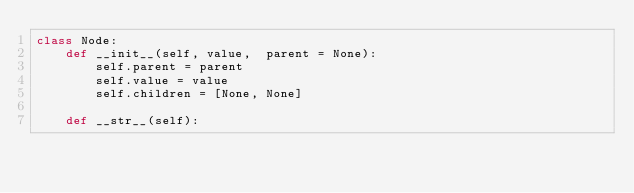Convert code to text. <code><loc_0><loc_0><loc_500><loc_500><_Python_>class Node:
    def __init__(self, value,  parent = None):
        self.parent = parent
        self.value = value
        self.children = [None, None]
    
    def __str__(self):</code> 